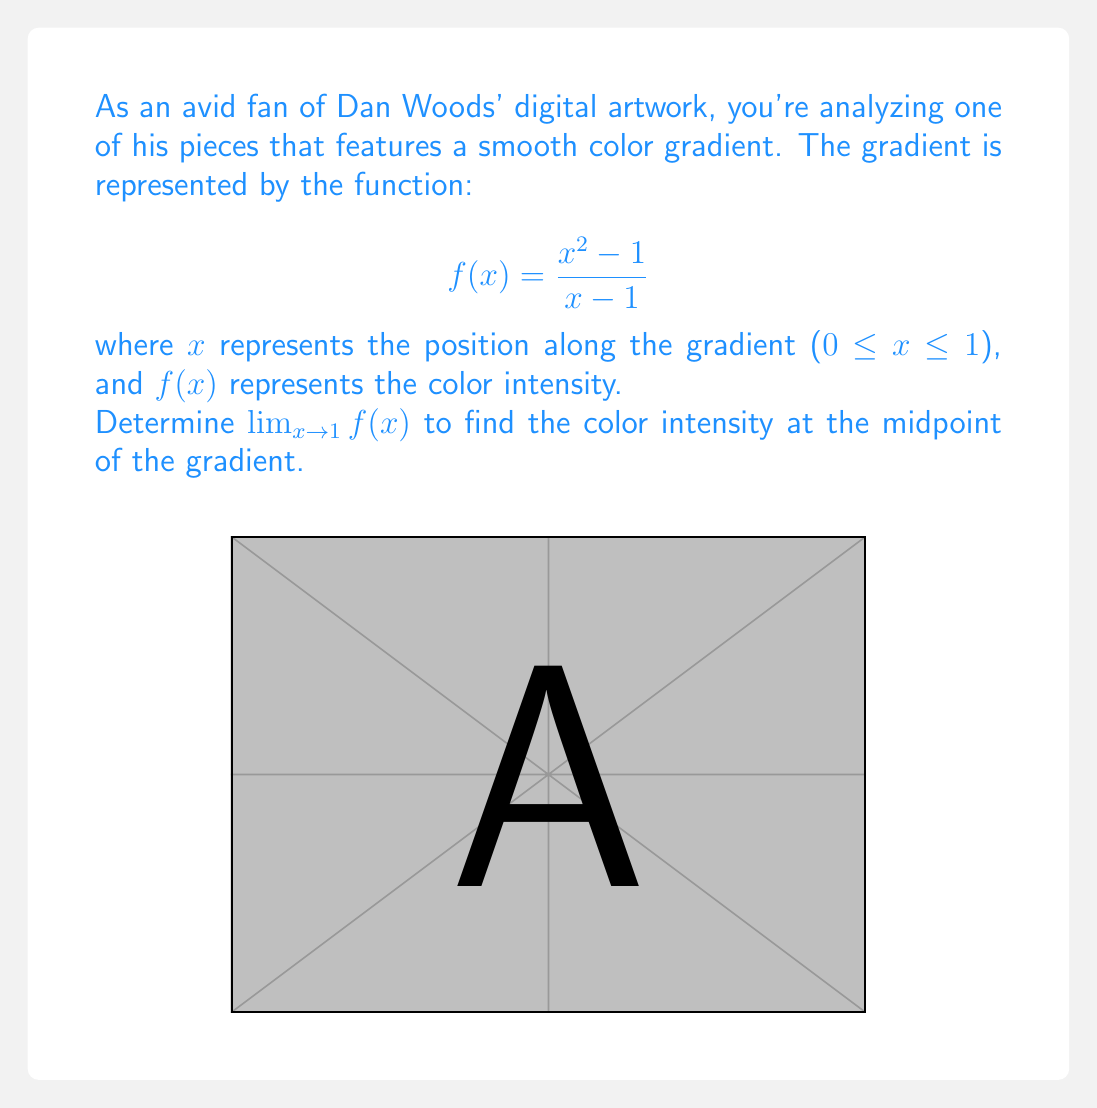Show me your answer to this math problem. Let's approach this step-by-step:

1) First, we need to recognize that this is an indeterminate form. If we directly substitute x=1, we get:

   $$f(1) = \frac{1^2 - 1}{1 - 1} = \frac{0}{0}$$

2) This 0/0 form suggests we need to factor the numerator:

   $$f(x) = \frac{x^2 - 1}{x - 1} = \frac{(x+1)(x-1)}{x - 1}$$

3) Now we can cancel the (x-1) term in the numerator and denominator:

   $$f(x) = \frac{(x+1)\cancel{(x-1)}}{\cancel{x - 1}} = x + 1$$

4) After this simplification, we can now evaluate the limit:

   $$\lim_{x \to 1} f(x) = \lim_{x \to 1} (x + 1) = 1 + 1 = 2$$

5) This means that as x approaches 1 (the midpoint of the gradient), the function approaches 2.

In the context of Dan Woods' artwork, this indicates that the color intensity at the midpoint of the gradient is 2 on whatever scale is being used.
Answer: 2 